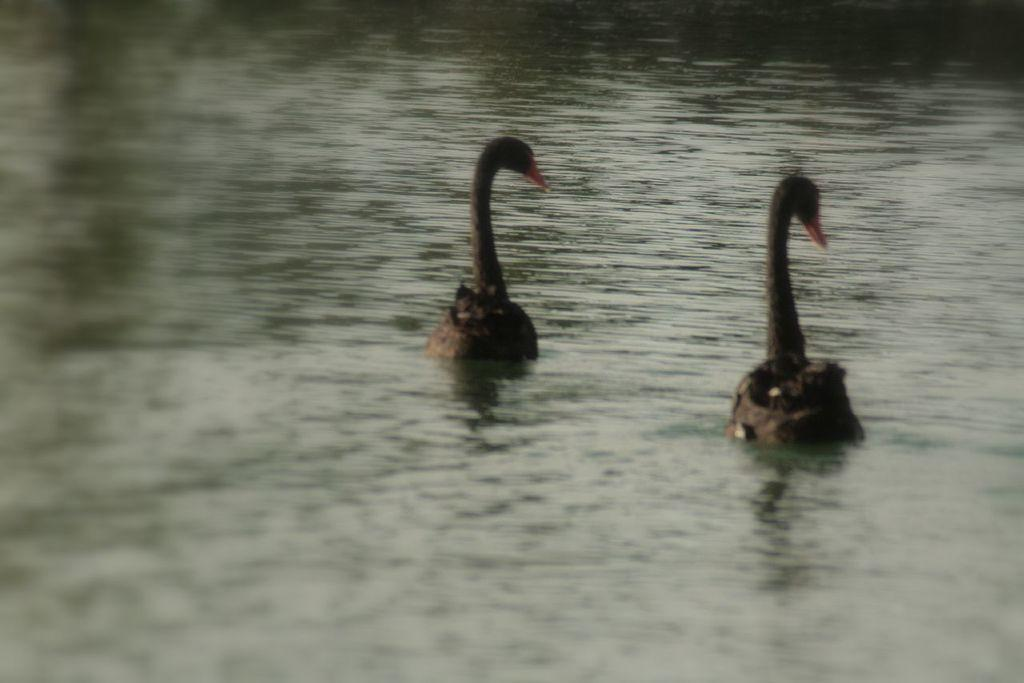What type of animals can be seen in the image? Birds can be seen in the image. Where are the birds located in the image? The birds are in the center of the image. How many birds are driving a car in the image? There are no birds driving a car in the image; the birds are in the water. 